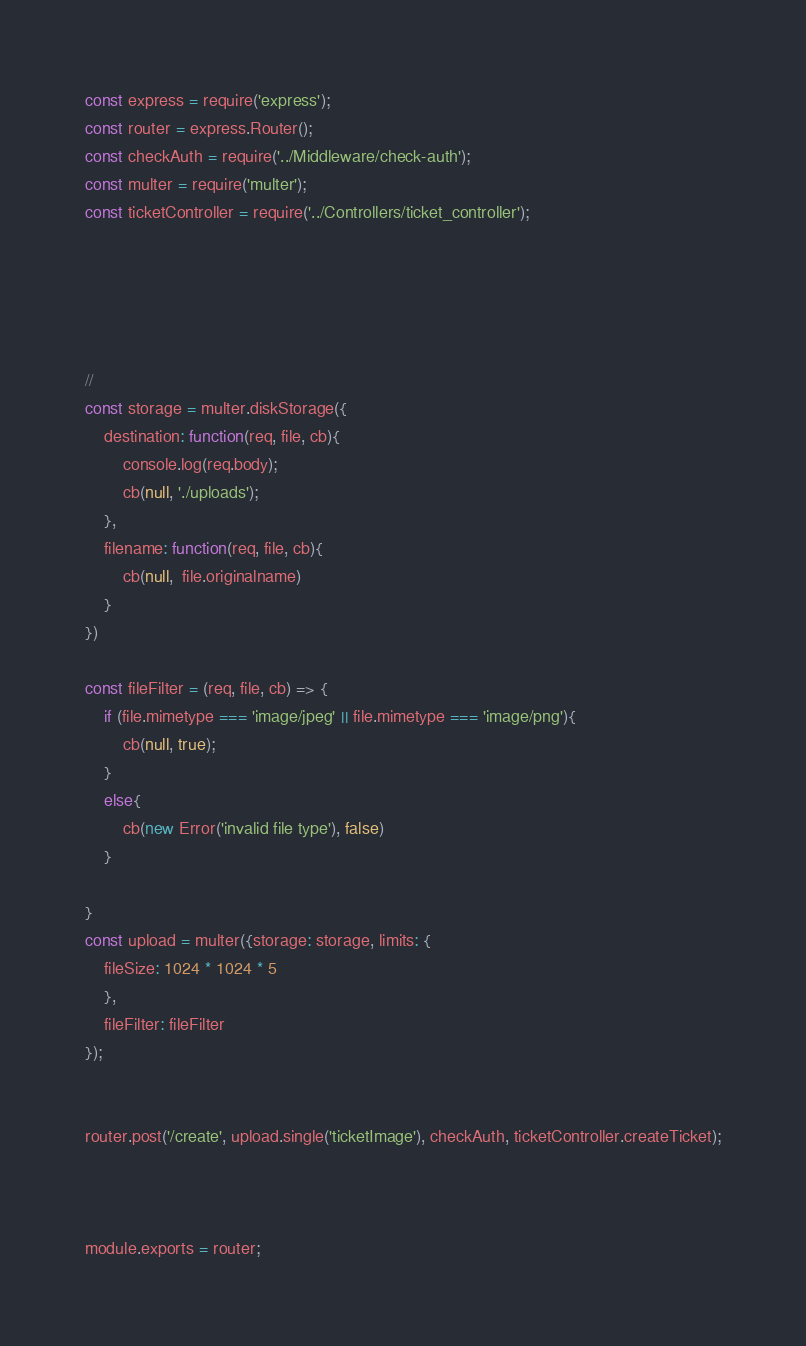Convert code to text. <code><loc_0><loc_0><loc_500><loc_500><_JavaScript_>const express = require('express');
const router = express.Router();
const checkAuth = require('../Middleware/check-auth');
const multer = require('multer');
const ticketController = require('../Controllers/ticket_controller');





//
const storage = multer.diskStorage({
    destination: function(req, file, cb){
        console.log(req.body);
        cb(null, './uploads');
    },
    filename: function(req, file, cb){
        cb(null,  file.originalname)
    }
})

const fileFilter = (req, file, cb) => {
    if (file.mimetype === 'image/jpeg' || file.mimetype === 'image/png'){
        cb(null, true);
    }
    else{
        cb(new Error('invalid file type'), false)
    }
     
}
const upload = multer({storage: storage, limits: {
    fileSize: 1024 * 1024 * 5
    },
    fileFilter: fileFilter
});


router.post('/create', upload.single('ticketImage'), checkAuth, ticketController.createTicket);



module.exports = router;</code> 